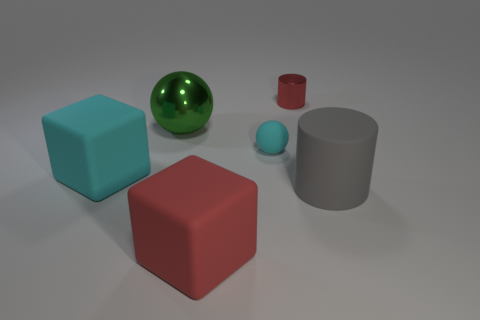Add 1 big purple cylinders. How many objects exist? 7 Subtract all spheres. How many objects are left? 4 Subtract 2 balls. How many balls are left? 0 Subtract all red spheres. Subtract all red cylinders. How many spheres are left? 2 Subtract all cyan cylinders. How many cyan blocks are left? 1 Subtract all tiny blue cylinders. Subtract all metallic objects. How many objects are left? 4 Add 1 cubes. How many cubes are left? 3 Add 4 large green shiny objects. How many large green shiny objects exist? 5 Subtract 0 yellow cylinders. How many objects are left? 6 